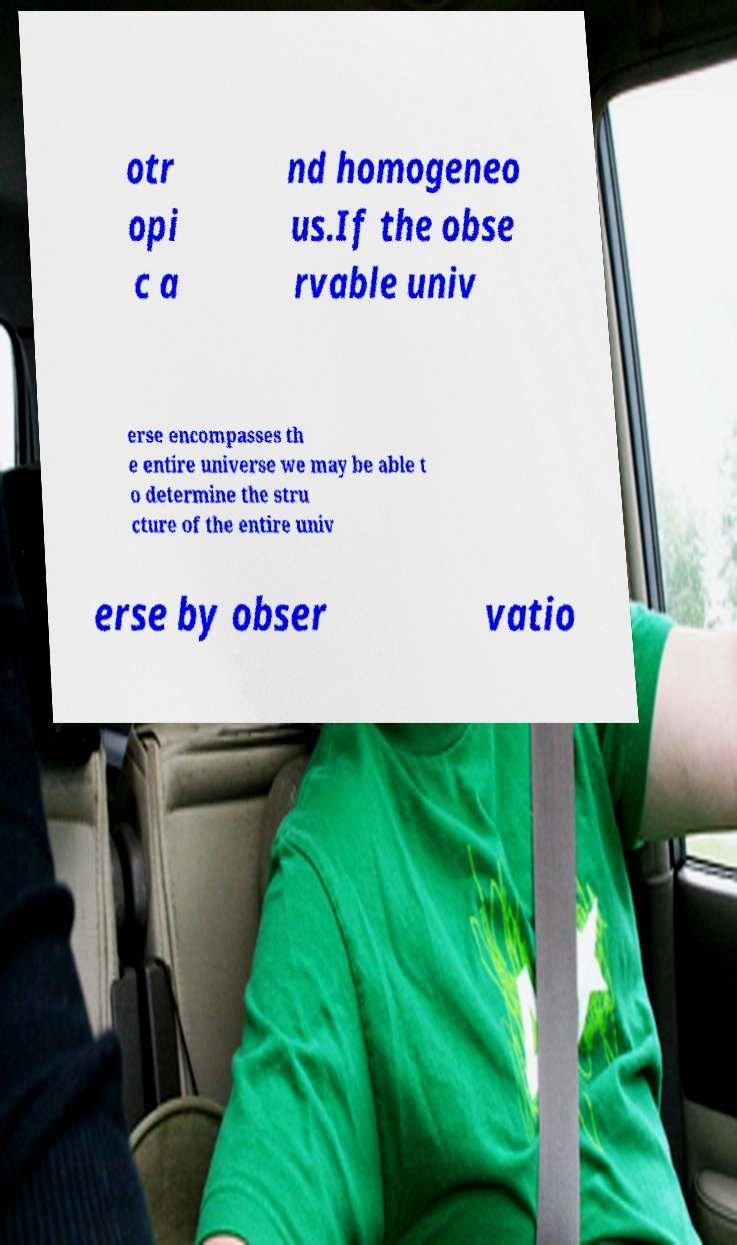I need the written content from this picture converted into text. Can you do that? otr opi c a nd homogeneo us.If the obse rvable univ erse encompasses th e entire universe we may be able t o determine the stru cture of the entire univ erse by obser vatio 